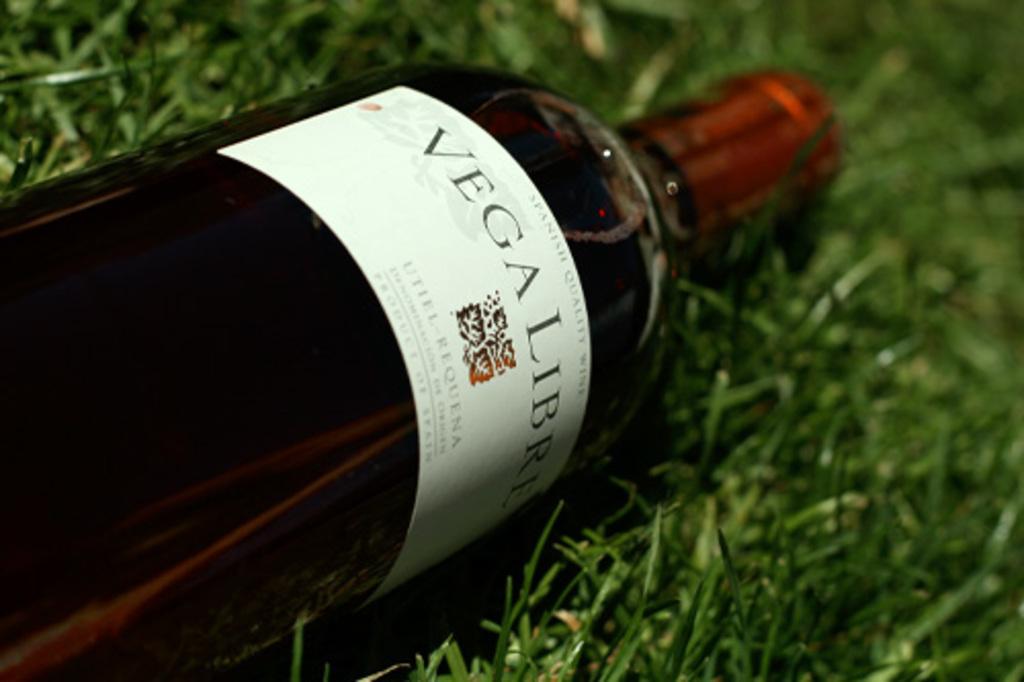What is the first word on the bottle?
Your response must be concise. Vega. 